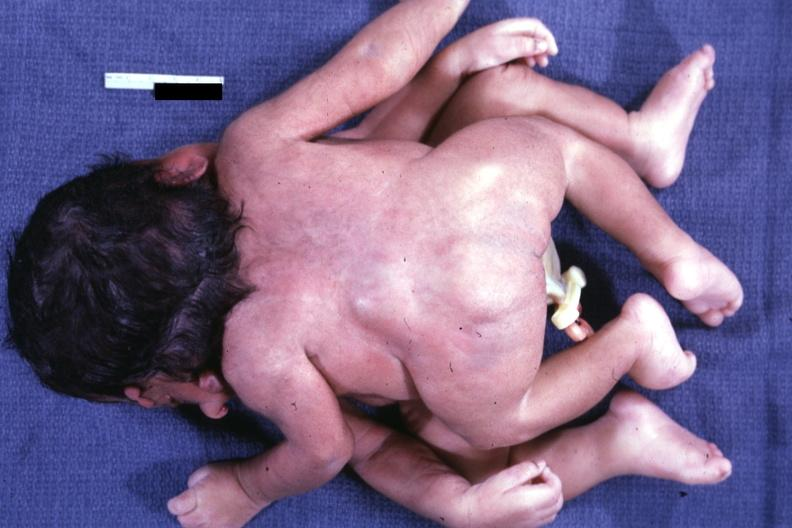what does this image show?
Answer the question using a single word or phrase. Twins joined at head facing each other 